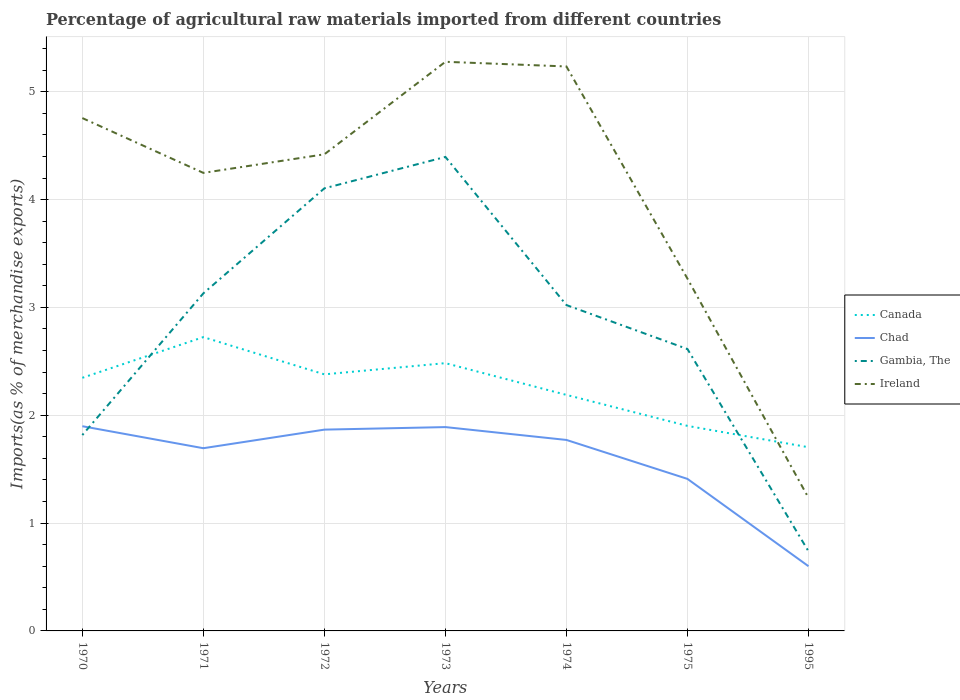How many different coloured lines are there?
Offer a very short reply. 4. Does the line corresponding to Gambia, The intersect with the line corresponding to Canada?
Your answer should be very brief. Yes. Is the number of lines equal to the number of legend labels?
Give a very brief answer. Yes. Across all years, what is the maximum percentage of imports to different countries in Gambia, The?
Your answer should be very brief. 0.74. What is the total percentage of imports to different countries in Gambia, The in the graph?
Your answer should be compact. 2.28. What is the difference between the highest and the second highest percentage of imports to different countries in Ireland?
Make the answer very short. 4.04. How many years are there in the graph?
Offer a terse response. 7. What is the difference between two consecutive major ticks on the Y-axis?
Keep it short and to the point. 1. Does the graph contain any zero values?
Provide a short and direct response. No. Does the graph contain grids?
Ensure brevity in your answer.  Yes. How many legend labels are there?
Give a very brief answer. 4. How are the legend labels stacked?
Offer a terse response. Vertical. What is the title of the graph?
Provide a short and direct response. Percentage of agricultural raw materials imported from different countries. What is the label or title of the X-axis?
Provide a short and direct response. Years. What is the label or title of the Y-axis?
Offer a very short reply. Imports(as % of merchandise exports). What is the Imports(as % of merchandise exports) of Canada in 1970?
Offer a very short reply. 2.35. What is the Imports(as % of merchandise exports) in Chad in 1970?
Your answer should be very brief. 1.9. What is the Imports(as % of merchandise exports) of Gambia, The in 1970?
Your response must be concise. 1.82. What is the Imports(as % of merchandise exports) in Ireland in 1970?
Your answer should be very brief. 4.76. What is the Imports(as % of merchandise exports) in Canada in 1971?
Keep it short and to the point. 2.72. What is the Imports(as % of merchandise exports) of Chad in 1971?
Offer a very short reply. 1.69. What is the Imports(as % of merchandise exports) in Gambia, The in 1971?
Give a very brief answer. 3.13. What is the Imports(as % of merchandise exports) of Ireland in 1971?
Your response must be concise. 4.25. What is the Imports(as % of merchandise exports) of Canada in 1972?
Your answer should be compact. 2.38. What is the Imports(as % of merchandise exports) in Chad in 1972?
Make the answer very short. 1.87. What is the Imports(as % of merchandise exports) of Gambia, The in 1972?
Keep it short and to the point. 4.1. What is the Imports(as % of merchandise exports) in Ireland in 1972?
Give a very brief answer. 4.42. What is the Imports(as % of merchandise exports) in Canada in 1973?
Your answer should be compact. 2.48. What is the Imports(as % of merchandise exports) in Chad in 1973?
Give a very brief answer. 1.89. What is the Imports(as % of merchandise exports) in Gambia, The in 1973?
Make the answer very short. 4.4. What is the Imports(as % of merchandise exports) of Ireland in 1973?
Offer a very short reply. 5.28. What is the Imports(as % of merchandise exports) of Canada in 1974?
Offer a terse response. 2.19. What is the Imports(as % of merchandise exports) in Chad in 1974?
Make the answer very short. 1.77. What is the Imports(as % of merchandise exports) of Gambia, The in 1974?
Offer a terse response. 3.02. What is the Imports(as % of merchandise exports) in Ireland in 1974?
Your response must be concise. 5.23. What is the Imports(as % of merchandise exports) in Canada in 1975?
Your response must be concise. 1.9. What is the Imports(as % of merchandise exports) in Chad in 1975?
Your response must be concise. 1.41. What is the Imports(as % of merchandise exports) of Gambia, The in 1975?
Offer a very short reply. 2.61. What is the Imports(as % of merchandise exports) of Ireland in 1975?
Provide a succinct answer. 3.27. What is the Imports(as % of merchandise exports) of Canada in 1995?
Your answer should be compact. 1.7. What is the Imports(as % of merchandise exports) of Chad in 1995?
Offer a very short reply. 0.6. What is the Imports(as % of merchandise exports) in Gambia, The in 1995?
Offer a terse response. 0.74. What is the Imports(as % of merchandise exports) in Ireland in 1995?
Make the answer very short. 1.23. Across all years, what is the maximum Imports(as % of merchandise exports) in Canada?
Offer a very short reply. 2.72. Across all years, what is the maximum Imports(as % of merchandise exports) in Chad?
Your answer should be very brief. 1.9. Across all years, what is the maximum Imports(as % of merchandise exports) of Gambia, The?
Offer a terse response. 4.4. Across all years, what is the maximum Imports(as % of merchandise exports) in Ireland?
Keep it short and to the point. 5.28. Across all years, what is the minimum Imports(as % of merchandise exports) in Canada?
Provide a short and direct response. 1.7. Across all years, what is the minimum Imports(as % of merchandise exports) of Chad?
Offer a terse response. 0.6. Across all years, what is the minimum Imports(as % of merchandise exports) of Gambia, The?
Your answer should be very brief. 0.74. Across all years, what is the minimum Imports(as % of merchandise exports) in Ireland?
Your answer should be very brief. 1.23. What is the total Imports(as % of merchandise exports) in Canada in the graph?
Ensure brevity in your answer.  15.73. What is the total Imports(as % of merchandise exports) in Chad in the graph?
Ensure brevity in your answer.  11.13. What is the total Imports(as % of merchandise exports) of Gambia, The in the graph?
Provide a short and direct response. 19.82. What is the total Imports(as % of merchandise exports) in Ireland in the graph?
Your answer should be compact. 28.44. What is the difference between the Imports(as % of merchandise exports) of Canada in 1970 and that in 1971?
Your response must be concise. -0.38. What is the difference between the Imports(as % of merchandise exports) of Chad in 1970 and that in 1971?
Offer a terse response. 0.2. What is the difference between the Imports(as % of merchandise exports) of Gambia, The in 1970 and that in 1971?
Offer a very short reply. -1.31. What is the difference between the Imports(as % of merchandise exports) in Ireland in 1970 and that in 1971?
Keep it short and to the point. 0.51. What is the difference between the Imports(as % of merchandise exports) in Canada in 1970 and that in 1972?
Give a very brief answer. -0.03. What is the difference between the Imports(as % of merchandise exports) of Chad in 1970 and that in 1972?
Provide a succinct answer. 0.03. What is the difference between the Imports(as % of merchandise exports) in Gambia, The in 1970 and that in 1972?
Your answer should be compact. -2.29. What is the difference between the Imports(as % of merchandise exports) of Ireland in 1970 and that in 1972?
Make the answer very short. 0.34. What is the difference between the Imports(as % of merchandise exports) of Canada in 1970 and that in 1973?
Make the answer very short. -0.14. What is the difference between the Imports(as % of merchandise exports) in Chad in 1970 and that in 1973?
Keep it short and to the point. 0.01. What is the difference between the Imports(as % of merchandise exports) of Gambia, The in 1970 and that in 1973?
Your answer should be compact. -2.58. What is the difference between the Imports(as % of merchandise exports) of Ireland in 1970 and that in 1973?
Your response must be concise. -0.52. What is the difference between the Imports(as % of merchandise exports) of Canada in 1970 and that in 1974?
Give a very brief answer. 0.16. What is the difference between the Imports(as % of merchandise exports) in Chad in 1970 and that in 1974?
Give a very brief answer. 0.13. What is the difference between the Imports(as % of merchandise exports) in Gambia, The in 1970 and that in 1974?
Provide a short and direct response. -1.21. What is the difference between the Imports(as % of merchandise exports) in Ireland in 1970 and that in 1974?
Make the answer very short. -0.48. What is the difference between the Imports(as % of merchandise exports) in Canada in 1970 and that in 1975?
Offer a terse response. 0.45. What is the difference between the Imports(as % of merchandise exports) in Chad in 1970 and that in 1975?
Give a very brief answer. 0.49. What is the difference between the Imports(as % of merchandise exports) in Gambia, The in 1970 and that in 1975?
Ensure brevity in your answer.  -0.8. What is the difference between the Imports(as % of merchandise exports) in Ireland in 1970 and that in 1975?
Offer a terse response. 1.49. What is the difference between the Imports(as % of merchandise exports) of Canada in 1970 and that in 1995?
Your answer should be very brief. 0.64. What is the difference between the Imports(as % of merchandise exports) of Chad in 1970 and that in 1995?
Offer a terse response. 1.3. What is the difference between the Imports(as % of merchandise exports) in Gambia, The in 1970 and that in 1995?
Offer a terse response. 1.08. What is the difference between the Imports(as % of merchandise exports) in Ireland in 1970 and that in 1995?
Offer a very short reply. 3.52. What is the difference between the Imports(as % of merchandise exports) in Canada in 1971 and that in 1972?
Offer a very short reply. 0.35. What is the difference between the Imports(as % of merchandise exports) of Chad in 1971 and that in 1972?
Your answer should be very brief. -0.17. What is the difference between the Imports(as % of merchandise exports) in Gambia, The in 1971 and that in 1972?
Your answer should be compact. -0.97. What is the difference between the Imports(as % of merchandise exports) of Ireland in 1971 and that in 1972?
Ensure brevity in your answer.  -0.17. What is the difference between the Imports(as % of merchandise exports) of Canada in 1971 and that in 1973?
Keep it short and to the point. 0.24. What is the difference between the Imports(as % of merchandise exports) of Chad in 1971 and that in 1973?
Your answer should be compact. -0.2. What is the difference between the Imports(as % of merchandise exports) in Gambia, The in 1971 and that in 1973?
Your response must be concise. -1.26. What is the difference between the Imports(as % of merchandise exports) of Ireland in 1971 and that in 1973?
Ensure brevity in your answer.  -1.03. What is the difference between the Imports(as % of merchandise exports) of Canada in 1971 and that in 1974?
Provide a succinct answer. 0.54. What is the difference between the Imports(as % of merchandise exports) in Chad in 1971 and that in 1974?
Your answer should be very brief. -0.08. What is the difference between the Imports(as % of merchandise exports) of Gambia, The in 1971 and that in 1974?
Your response must be concise. 0.11. What is the difference between the Imports(as % of merchandise exports) in Ireland in 1971 and that in 1974?
Give a very brief answer. -0.99. What is the difference between the Imports(as % of merchandise exports) in Canada in 1971 and that in 1975?
Offer a very short reply. 0.82. What is the difference between the Imports(as % of merchandise exports) of Chad in 1971 and that in 1975?
Ensure brevity in your answer.  0.28. What is the difference between the Imports(as % of merchandise exports) in Gambia, The in 1971 and that in 1975?
Give a very brief answer. 0.52. What is the difference between the Imports(as % of merchandise exports) of Ireland in 1971 and that in 1975?
Make the answer very short. 0.98. What is the difference between the Imports(as % of merchandise exports) in Canada in 1971 and that in 1995?
Make the answer very short. 1.02. What is the difference between the Imports(as % of merchandise exports) in Chad in 1971 and that in 1995?
Offer a very short reply. 1.09. What is the difference between the Imports(as % of merchandise exports) of Gambia, The in 1971 and that in 1995?
Offer a terse response. 2.39. What is the difference between the Imports(as % of merchandise exports) in Ireland in 1971 and that in 1995?
Provide a succinct answer. 3.01. What is the difference between the Imports(as % of merchandise exports) in Canada in 1972 and that in 1973?
Provide a short and direct response. -0.1. What is the difference between the Imports(as % of merchandise exports) of Chad in 1972 and that in 1973?
Offer a terse response. -0.02. What is the difference between the Imports(as % of merchandise exports) of Gambia, The in 1972 and that in 1973?
Give a very brief answer. -0.29. What is the difference between the Imports(as % of merchandise exports) in Ireland in 1972 and that in 1973?
Offer a terse response. -0.86. What is the difference between the Imports(as % of merchandise exports) in Canada in 1972 and that in 1974?
Your answer should be compact. 0.19. What is the difference between the Imports(as % of merchandise exports) of Chad in 1972 and that in 1974?
Keep it short and to the point. 0.1. What is the difference between the Imports(as % of merchandise exports) in Gambia, The in 1972 and that in 1974?
Offer a terse response. 1.08. What is the difference between the Imports(as % of merchandise exports) in Ireland in 1972 and that in 1974?
Offer a very short reply. -0.81. What is the difference between the Imports(as % of merchandise exports) in Canada in 1972 and that in 1975?
Your answer should be very brief. 0.48. What is the difference between the Imports(as % of merchandise exports) in Chad in 1972 and that in 1975?
Your response must be concise. 0.46. What is the difference between the Imports(as % of merchandise exports) of Gambia, The in 1972 and that in 1975?
Offer a very short reply. 1.49. What is the difference between the Imports(as % of merchandise exports) of Ireland in 1972 and that in 1975?
Keep it short and to the point. 1.15. What is the difference between the Imports(as % of merchandise exports) in Canada in 1972 and that in 1995?
Provide a succinct answer. 0.68. What is the difference between the Imports(as % of merchandise exports) in Chad in 1972 and that in 1995?
Make the answer very short. 1.27. What is the difference between the Imports(as % of merchandise exports) in Gambia, The in 1972 and that in 1995?
Make the answer very short. 3.37. What is the difference between the Imports(as % of merchandise exports) in Ireland in 1972 and that in 1995?
Ensure brevity in your answer.  3.19. What is the difference between the Imports(as % of merchandise exports) of Canada in 1973 and that in 1974?
Offer a terse response. 0.29. What is the difference between the Imports(as % of merchandise exports) in Chad in 1973 and that in 1974?
Your response must be concise. 0.12. What is the difference between the Imports(as % of merchandise exports) of Gambia, The in 1973 and that in 1974?
Offer a very short reply. 1.37. What is the difference between the Imports(as % of merchandise exports) of Ireland in 1973 and that in 1974?
Your answer should be very brief. 0.04. What is the difference between the Imports(as % of merchandise exports) in Canada in 1973 and that in 1975?
Ensure brevity in your answer.  0.58. What is the difference between the Imports(as % of merchandise exports) in Chad in 1973 and that in 1975?
Ensure brevity in your answer.  0.48. What is the difference between the Imports(as % of merchandise exports) in Gambia, The in 1973 and that in 1975?
Your response must be concise. 1.78. What is the difference between the Imports(as % of merchandise exports) in Ireland in 1973 and that in 1975?
Provide a short and direct response. 2.01. What is the difference between the Imports(as % of merchandise exports) in Canada in 1973 and that in 1995?
Make the answer very short. 0.78. What is the difference between the Imports(as % of merchandise exports) of Chad in 1973 and that in 1995?
Provide a succinct answer. 1.29. What is the difference between the Imports(as % of merchandise exports) of Gambia, The in 1973 and that in 1995?
Make the answer very short. 3.66. What is the difference between the Imports(as % of merchandise exports) of Ireland in 1973 and that in 1995?
Keep it short and to the point. 4.04. What is the difference between the Imports(as % of merchandise exports) of Canada in 1974 and that in 1975?
Your answer should be very brief. 0.29. What is the difference between the Imports(as % of merchandise exports) of Chad in 1974 and that in 1975?
Provide a short and direct response. 0.36. What is the difference between the Imports(as % of merchandise exports) of Gambia, The in 1974 and that in 1975?
Ensure brevity in your answer.  0.41. What is the difference between the Imports(as % of merchandise exports) of Ireland in 1974 and that in 1975?
Your response must be concise. 1.97. What is the difference between the Imports(as % of merchandise exports) in Canada in 1974 and that in 1995?
Offer a terse response. 0.49. What is the difference between the Imports(as % of merchandise exports) of Chad in 1974 and that in 1995?
Give a very brief answer. 1.17. What is the difference between the Imports(as % of merchandise exports) in Gambia, The in 1974 and that in 1995?
Provide a succinct answer. 2.28. What is the difference between the Imports(as % of merchandise exports) of Canada in 1975 and that in 1995?
Provide a succinct answer. 0.2. What is the difference between the Imports(as % of merchandise exports) in Chad in 1975 and that in 1995?
Your answer should be compact. 0.81. What is the difference between the Imports(as % of merchandise exports) of Gambia, The in 1975 and that in 1995?
Ensure brevity in your answer.  1.88. What is the difference between the Imports(as % of merchandise exports) of Ireland in 1975 and that in 1995?
Provide a succinct answer. 2.03. What is the difference between the Imports(as % of merchandise exports) in Canada in 1970 and the Imports(as % of merchandise exports) in Chad in 1971?
Your answer should be very brief. 0.65. What is the difference between the Imports(as % of merchandise exports) of Canada in 1970 and the Imports(as % of merchandise exports) of Gambia, The in 1971?
Offer a terse response. -0.78. What is the difference between the Imports(as % of merchandise exports) in Canada in 1970 and the Imports(as % of merchandise exports) in Ireland in 1971?
Ensure brevity in your answer.  -1.9. What is the difference between the Imports(as % of merchandise exports) of Chad in 1970 and the Imports(as % of merchandise exports) of Gambia, The in 1971?
Provide a short and direct response. -1.23. What is the difference between the Imports(as % of merchandise exports) in Chad in 1970 and the Imports(as % of merchandise exports) in Ireland in 1971?
Keep it short and to the point. -2.35. What is the difference between the Imports(as % of merchandise exports) in Gambia, The in 1970 and the Imports(as % of merchandise exports) in Ireland in 1971?
Provide a succinct answer. -2.43. What is the difference between the Imports(as % of merchandise exports) in Canada in 1970 and the Imports(as % of merchandise exports) in Chad in 1972?
Your answer should be compact. 0.48. What is the difference between the Imports(as % of merchandise exports) of Canada in 1970 and the Imports(as % of merchandise exports) of Gambia, The in 1972?
Offer a very short reply. -1.76. What is the difference between the Imports(as % of merchandise exports) of Canada in 1970 and the Imports(as % of merchandise exports) of Ireland in 1972?
Make the answer very short. -2.07. What is the difference between the Imports(as % of merchandise exports) in Chad in 1970 and the Imports(as % of merchandise exports) in Gambia, The in 1972?
Ensure brevity in your answer.  -2.21. What is the difference between the Imports(as % of merchandise exports) of Chad in 1970 and the Imports(as % of merchandise exports) of Ireland in 1972?
Offer a terse response. -2.52. What is the difference between the Imports(as % of merchandise exports) of Gambia, The in 1970 and the Imports(as % of merchandise exports) of Ireland in 1972?
Your answer should be very brief. -2.6. What is the difference between the Imports(as % of merchandise exports) of Canada in 1970 and the Imports(as % of merchandise exports) of Chad in 1973?
Ensure brevity in your answer.  0.46. What is the difference between the Imports(as % of merchandise exports) of Canada in 1970 and the Imports(as % of merchandise exports) of Gambia, The in 1973?
Give a very brief answer. -2.05. What is the difference between the Imports(as % of merchandise exports) of Canada in 1970 and the Imports(as % of merchandise exports) of Ireland in 1973?
Keep it short and to the point. -2.93. What is the difference between the Imports(as % of merchandise exports) of Chad in 1970 and the Imports(as % of merchandise exports) of Gambia, The in 1973?
Provide a short and direct response. -2.5. What is the difference between the Imports(as % of merchandise exports) in Chad in 1970 and the Imports(as % of merchandise exports) in Ireland in 1973?
Make the answer very short. -3.38. What is the difference between the Imports(as % of merchandise exports) in Gambia, The in 1970 and the Imports(as % of merchandise exports) in Ireland in 1973?
Your answer should be compact. -3.46. What is the difference between the Imports(as % of merchandise exports) in Canada in 1970 and the Imports(as % of merchandise exports) in Chad in 1974?
Offer a terse response. 0.58. What is the difference between the Imports(as % of merchandise exports) of Canada in 1970 and the Imports(as % of merchandise exports) of Gambia, The in 1974?
Ensure brevity in your answer.  -0.67. What is the difference between the Imports(as % of merchandise exports) in Canada in 1970 and the Imports(as % of merchandise exports) in Ireland in 1974?
Offer a very short reply. -2.89. What is the difference between the Imports(as % of merchandise exports) of Chad in 1970 and the Imports(as % of merchandise exports) of Gambia, The in 1974?
Offer a very short reply. -1.12. What is the difference between the Imports(as % of merchandise exports) in Chad in 1970 and the Imports(as % of merchandise exports) in Ireland in 1974?
Ensure brevity in your answer.  -3.34. What is the difference between the Imports(as % of merchandise exports) of Gambia, The in 1970 and the Imports(as % of merchandise exports) of Ireland in 1974?
Your response must be concise. -3.42. What is the difference between the Imports(as % of merchandise exports) of Canada in 1970 and the Imports(as % of merchandise exports) of Gambia, The in 1975?
Give a very brief answer. -0.27. What is the difference between the Imports(as % of merchandise exports) of Canada in 1970 and the Imports(as % of merchandise exports) of Ireland in 1975?
Offer a very short reply. -0.92. What is the difference between the Imports(as % of merchandise exports) of Chad in 1970 and the Imports(as % of merchandise exports) of Gambia, The in 1975?
Your answer should be compact. -0.72. What is the difference between the Imports(as % of merchandise exports) of Chad in 1970 and the Imports(as % of merchandise exports) of Ireland in 1975?
Provide a succinct answer. -1.37. What is the difference between the Imports(as % of merchandise exports) in Gambia, The in 1970 and the Imports(as % of merchandise exports) in Ireland in 1975?
Offer a terse response. -1.45. What is the difference between the Imports(as % of merchandise exports) in Canada in 1970 and the Imports(as % of merchandise exports) in Chad in 1995?
Provide a succinct answer. 1.75. What is the difference between the Imports(as % of merchandise exports) in Canada in 1970 and the Imports(as % of merchandise exports) in Gambia, The in 1995?
Ensure brevity in your answer.  1.61. What is the difference between the Imports(as % of merchandise exports) in Canada in 1970 and the Imports(as % of merchandise exports) in Ireland in 1995?
Your response must be concise. 1.11. What is the difference between the Imports(as % of merchandise exports) in Chad in 1970 and the Imports(as % of merchandise exports) in Gambia, The in 1995?
Ensure brevity in your answer.  1.16. What is the difference between the Imports(as % of merchandise exports) of Chad in 1970 and the Imports(as % of merchandise exports) of Ireland in 1995?
Your response must be concise. 0.66. What is the difference between the Imports(as % of merchandise exports) in Gambia, The in 1970 and the Imports(as % of merchandise exports) in Ireland in 1995?
Offer a terse response. 0.58. What is the difference between the Imports(as % of merchandise exports) in Canada in 1971 and the Imports(as % of merchandise exports) in Chad in 1972?
Your answer should be very brief. 0.86. What is the difference between the Imports(as % of merchandise exports) of Canada in 1971 and the Imports(as % of merchandise exports) of Gambia, The in 1972?
Your answer should be compact. -1.38. What is the difference between the Imports(as % of merchandise exports) in Canada in 1971 and the Imports(as % of merchandise exports) in Ireland in 1972?
Give a very brief answer. -1.7. What is the difference between the Imports(as % of merchandise exports) in Chad in 1971 and the Imports(as % of merchandise exports) in Gambia, The in 1972?
Your response must be concise. -2.41. What is the difference between the Imports(as % of merchandise exports) of Chad in 1971 and the Imports(as % of merchandise exports) of Ireland in 1972?
Offer a very short reply. -2.73. What is the difference between the Imports(as % of merchandise exports) of Gambia, The in 1971 and the Imports(as % of merchandise exports) of Ireland in 1972?
Provide a succinct answer. -1.29. What is the difference between the Imports(as % of merchandise exports) in Canada in 1971 and the Imports(as % of merchandise exports) in Chad in 1973?
Your answer should be compact. 0.83. What is the difference between the Imports(as % of merchandise exports) in Canada in 1971 and the Imports(as % of merchandise exports) in Gambia, The in 1973?
Give a very brief answer. -1.67. What is the difference between the Imports(as % of merchandise exports) of Canada in 1971 and the Imports(as % of merchandise exports) of Ireland in 1973?
Offer a terse response. -2.55. What is the difference between the Imports(as % of merchandise exports) of Chad in 1971 and the Imports(as % of merchandise exports) of Gambia, The in 1973?
Make the answer very short. -2.7. What is the difference between the Imports(as % of merchandise exports) of Chad in 1971 and the Imports(as % of merchandise exports) of Ireland in 1973?
Make the answer very short. -3.58. What is the difference between the Imports(as % of merchandise exports) of Gambia, The in 1971 and the Imports(as % of merchandise exports) of Ireland in 1973?
Offer a very short reply. -2.15. What is the difference between the Imports(as % of merchandise exports) in Canada in 1971 and the Imports(as % of merchandise exports) in Chad in 1974?
Give a very brief answer. 0.95. What is the difference between the Imports(as % of merchandise exports) of Canada in 1971 and the Imports(as % of merchandise exports) of Gambia, The in 1974?
Offer a very short reply. -0.3. What is the difference between the Imports(as % of merchandise exports) of Canada in 1971 and the Imports(as % of merchandise exports) of Ireland in 1974?
Your answer should be compact. -2.51. What is the difference between the Imports(as % of merchandise exports) of Chad in 1971 and the Imports(as % of merchandise exports) of Gambia, The in 1974?
Your answer should be very brief. -1.33. What is the difference between the Imports(as % of merchandise exports) in Chad in 1971 and the Imports(as % of merchandise exports) in Ireland in 1974?
Offer a terse response. -3.54. What is the difference between the Imports(as % of merchandise exports) of Gambia, The in 1971 and the Imports(as % of merchandise exports) of Ireland in 1974?
Keep it short and to the point. -2.1. What is the difference between the Imports(as % of merchandise exports) of Canada in 1971 and the Imports(as % of merchandise exports) of Chad in 1975?
Provide a succinct answer. 1.31. What is the difference between the Imports(as % of merchandise exports) of Canada in 1971 and the Imports(as % of merchandise exports) of Gambia, The in 1975?
Your answer should be very brief. 0.11. What is the difference between the Imports(as % of merchandise exports) of Canada in 1971 and the Imports(as % of merchandise exports) of Ireland in 1975?
Keep it short and to the point. -0.54. What is the difference between the Imports(as % of merchandise exports) of Chad in 1971 and the Imports(as % of merchandise exports) of Gambia, The in 1975?
Provide a short and direct response. -0.92. What is the difference between the Imports(as % of merchandise exports) in Chad in 1971 and the Imports(as % of merchandise exports) in Ireland in 1975?
Provide a succinct answer. -1.57. What is the difference between the Imports(as % of merchandise exports) in Gambia, The in 1971 and the Imports(as % of merchandise exports) in Ireland in 1975?
Keep it short and to the point. -0.14. What is the difference between the Imports(as % of merchandise exports) in Canada in 1971 and the Imports(as % of merchandise exports) in Chad in 1995?
Offer a terse response. 2.12. What is the difference between the Imports(as % of merchandise exports) in Canada in 1971 and the Imports(as % of merchandise exports) in Gambia, The in 1995?
Offer a very short reply. 1.99. What is the difference between the Imports(as % of merchandise exports) of Canada in 1971 and the Imports(as % of merchandise exports) of Ireland in 1995?
Ensure brevity in your answer.  1.49. What is the difference between the Imports(as % of merchandise exports) in Chad in 1971 and the Imports(as % of merchandise exports) in Gambia, The in 1995?
Offer a terse response. 0.96. What is the difference between the Imports(as % of merchandise exports) in Chad in 1971 and the Imports(as % of merchandise exports) in Ireland in 1995?
Your answer should be compact. 0.46. What is the difference between the Imports(as % of merchandise exports) of Gambia, The in 1971 and the Imports(as % of merchandise exports) of Ireland in 1995?
Your answer should be very brief. 1.9. What is the difference between the Imports(as % of merchandise exports) of Canada in 1972 and the Imports(as % of merchandise exports) of Chad in 1973?
Your answer should be very brief. 0.49. What is the difference between the Imports(as % of merchandise exports) of Canada in 1972 and the Imports(as % of merchandise exports) of Gambia, The in 1973?
Provide a short and direct response. -2.02. What is the difference between the Imports(as % of merchandise exports) in Canada in 1972 and the Imports(as % of merchandise exports) in Ireland in 1973?
Your response must be concise. -2.9. What is the difference between the Imports(as % of merchandise exports) of Chad in 1972 and the Imports(as % of merchandise exports) of Gambia, The in 1973?
Provide a succinct answer. -2.53. What is the difference between the Imports(as % of merchandise exports) in Chad in 1972 and the Imports(as % of merchandise exports) in Ireland in 1973?
Give a very brief answer. -3.41. What is the difference between the Imports(as % of merchandise exports) of Gambia, The in 1972 and the Imports(as % of merchandise exports) of Ireland in 1973?
Give a very brief answer. -1.17. What is the difference between the Imports(as % of merchandise exports) in Canada in 1972 and the Imports(as % of merchandise exports) in Chad in 1974?
Your answer should be very brief. 0.61. What is the difference between the Imports(as % of merchandise exports) of Canada in 1972 and the Imports(as % of merchandise exports) of Gambia, The in 1974?
Provide a short and direct response. -0.64. What is the difference between the Imports(as % of merchandise exports) of Canada in 1972 and the Imports(as % of merchandise exports) of Ireland in 1974?
Your answer should be very brief. -2.86. What is the difference between the Imports(as % of merchandise exports) of Chad in 1972 and the Imports(as % of merchandise exports) of Gambia, The in 1974?
Your response must be concise. -1.16. What is the difference between the Imports(as % of merchandise exports) in Chad in 1972 and the Imports(as % of merchandise exports) in Ireland in 1974?
Your answer should be compact. -3.37. What is the difference between the Imports(as % of merchandise exports) in Gambia, The in 1972 and the Imports(as % of merchandise exports) in Ireland in 1974?
Your answer should be very brief. -1.13. What is the difference between the Imports(as % of merchandise exports) of Canada in 1972 and the Imports(as % of merchandise exports) of Chad in 1975?
Your answer should be compact. 0.97. What is the difference between the Imports(as % of merchandise exports) of Canada in 1972 and the Imports(as % of merchandise exports) of Gambia, The in 1975?
Provide a short and direct response. -0.23. What is the difference between the Imports(as % of merchandise exports) of Canada in 1972 and the Imports(as % of merchandise exports) of Ireland in 1975?
Keep it short and to the point. -0.89. What is the difference between the Imports(as % of merchandise exports) in Chad in 1972 and the Imports(as % of merchandise exports) in Gambia, The in 1975?
Your answer should be very brief. -0.75. What is the difference between the Imports(as % of merchandise exports) in Chad in 1972 and the Imports(as % of merchandise exports) in Ireland in 1975?
Provide a succinct answer. -1.4. What is the difference between the Imports(as % of merchandise exports) in Gambia, The in 1972 and the Imports(as % of merchandise exports) in Ireland in 1975?
Your answer should be compact. 0.84. What is the difference between the Imports(as % of merchandise exports) of Canada in 1972 and the Imports(as % of merchandise exports) of Chad in 1995?
Make the answer very short. 1.78. What is the difference between the Imports(as % of merchandise exports) in Canada in 1972 and the Imports(as % of merchandise exports) in Gambia, The in 1995?
Your answer should be very brief. 1.64. What is the difference between the Imports(as % of merchandise exports) in Canada in 1972 and the Imports(as % of merchandise exports) in Ireland in 1995?
Provide a succinct answer. 1.14. What is the difference between the Imports(as % of merchandise exports) in Chad in 1972 and the Imports(as % of merchandise exports) in Gambia, The in 1995?
Your response must be concise. 1.13. What is the difference between the Imports(as % of merchandise exports) in Chad in 1972 and the Imports(as % of merchandise exports) in Ireland in 1995?
Provide a short and direct response. 0.63. What is the difference between the Imports(as % of merchandise exports) in Gambia, The in 1972 and the Imports(as % of merchandise exports) in Ireland in 1995?
Keep it short and to the point. 2.87. What is the difference between the Imports(as % of merchandise exports) in Canada in 1973 and the Imports(as % of merchandise exports) in Chad in 1974?
Give a very brief answer. 0.71. What is the difference between the Imports(as % of merchandise exports) in Canada in 1973 and the Imports(as % of merchandise exports) in Gambia, The in 1974?
Offer a terse response. -0.54. What is the difference between the Imports(as % of merchandise exports) of Canada in 1973 and the Imports(as % of merchandise exports) of Ireland in 1974?
Offer a very short reply. -2.75. What is the difference between the Imports(as % of merchandise exports) in Chad in 1973 and the Imports(as % of merchandise exports) in Gambia, The in 1974?
Keep it short and to the point. -1.13. What is the difference between the Imports(as % of merchandise exports) of Chad in 1973 and the Imports(as % of merchandise exports) of Ireland in 1974?
Provide a succinct answer. -3.34. What is the difference between the Imports(as % of merchandise exports) of Gambia, The in 1973 and the Imports(as % of merchandise exports) of Ireland in 1974?
Provide a succinct answer. -0.84. What is the difference between the Imports(as % of merchandise exports) in Canada in 1973 and the Imports(as % of merchandise exports) in Chad in 1975?
Make the answer very short. 1.07. What is the difference between the Imports(as % of merchandise exports) of Canada in 1973 and the Imports(as % of merchandise exports) of Gambia, The in 1975?
Make the answer very short. -0.13. What is the difference between the Imports(as % of merchandise exports) of Canada in 1973 and the Imports(as % of merchandise exports) of Ireland in 1975?
Offer a very short reply. -0.78. What is the difference between the Imports(as % of merchandise exports) of Chad in 1973 and the Imports(as % of merchandise exports) of Gambia, The in 1975?
Provide a succinct answer. -0.72. What is the difference between the Imports(as % of merchandise exports) in Chad in 1973 and the Imports(as % of merchandise exports) in Ireland in 1975?
Your response must be concise. -1.38. What is the difference between the Imports(as % of merchandise exports) of Gambia, The in 1973 and the Imports(as % of merchandise exports) of Ireland in 1975?
Provide a succinct answer. 1.13. What is the difference between the Imports(as % of merchandise exports) in Canada in 1973 and the Imports(as % of merchandise exports) in Chad in 1995?
Offer a very short reply. 1.88. What is the difference between the Imports(as % of merchandise exports) of Canada in 1973 and the Imports(as % of merchandise exports) of Gambia, The in 1995?
Offer a terse response. 1.74. What is the difference between the Imports(as % of merchandise exports) of Canada in 1973 and the Imports(as % of merchandise exports) of Ireland in 1995?
Offer a terse response. 1.25. What is the difference between the Imports(as % of merchandise exports) of Chad in 1973 and the Imports(as % of merchandise exports) of Gambia, The in 1995?
Your response must be concise. 1.15. What is the difference between the Imports(as % of merchandise exports) of Chad in 1973 and the Imports(as % of merchandise exports) of Ireland in 1995?
Provide a short and direct response. 0.66. What is the difference between the Imports(as % of merchandise exports) in Gambia, The in 1973 and the Imports(as % of merchandise exports) in Ireland in 1995?
Offer a very short reply. 3.16. What is the difference between the Imports(as % of merchandise exports) of Canada in 1974 and the Imports(as % of merchandise exports) of Chad in 1975?
Provide a short and direct response. 0.78. What is the difference between the Imports(as % of merchandise exports) of Canada in 1974 and the Imports(as % of merchandise exports) of Gambia, The in 1975?
Give a very brief answer. -0.43. What is the difference between the Imports(as % of merchandise exports) of Canada in 1974 and the Imports(as % of merchandise exports) of Ireland in 1975?
Your answer should be very brief. -1.08. What is the difference between the Imports(as % of merchandise exports) of Chad in 1974 and the Imports(as % of merchandise exports) of Gambia, The in 1975?
Keep it short and to the point. -0.84. What is the difference between the Imports(as % of merchandise exports) of Chad in 1974 and the Imports(as % of merchandise exports) of Ireland in 1975?
Give a very brief answer. -1.5. What is the difference between the Imports(as % of merchandise exports) in Gambia, The in 1974 and the Imports(as % of merchandise exports) in Ireland in 1975?
Provide a short and direct response. -0.25. What is the difference between the Imports(as % of merchandise exports) in Canada in 1974 and the Imports(as % of merchandise exports) in Chad in 1995?
Offer a terse response. 1.59. What is the difference between the Imports(as % of merchandise exports) in Canada in 1974 and the Imports(as % of merchandise exports) in Gambia, The in 1995?
Your response must be concise. 1.45. What is the difference between the Imports(as % of merchandise exports) of Canada in 1974 and the Imports(as % of merchandise exports) of Ireland in 1995?
Make the answer very short. 0.95. What is the difference between the Imports(as % of merchandise exports) of Chad in 1974 and the Imports(as % of merchandise exports) of Gambia, The in 1995?
Keep it short and to the point. 1.03. What is the difference between the Imports(as % of merchandise exports) in Chad in 1974 and the Imports(as % of merchandise exports) in Ireland in 1995?
Your answer should be compact. 0.54. What is the difference between the Imports(as % of merchandise exports) in Gambia, The in 1974 and the Imports(as % of merchandise exports) in Ireland in 1995?
Keep it short and to the point. 1.79. What is the difference between the Imports(as % of merchandise exports) in Canada in 1975 and the Imports(as % of merchandise exports) in Chad in 1995?
Your response must be concise. 1.3. What is the difference between the Imports(as % of merchandise exports) in Canada in 1975 and the Imports(as % of merchandise exports) in Gambia, The in 1995?
Make the answer very short. 1.16. What is the difference between the Imports(as % of merchandise exports) in Canada in 1975 and the Imports(as % of merchandise exports) in Ireland in 1995?
Provide a short and direct response. 0.67. What is the difference between the Imports(as % of merchandise exports) of Chad in 1975 and the Imports(as % of merchandise exports) of Gambia, The in 1995?
Ensure brevity in your answer.  0.67. What is the difference between the Imports(as % of merchandise exports) of Chad in 1975 and the Imports(as % of merchandise exports) of Ireland in 1995?
Offer a terse response. 0.18. What is the difference between the Imports(as % of merchandise exports) of Gambia, The in 1975 and the Imports(as % of merchandise exports) of Ireland in 1995?
Make the answer very short. 1.38. What is the average Imports(as % of merchandise exports) of Canada per year?
Your response must be concise. 2.25. What is the average Imports(as % of merchandise exports) of Chad per year?
Your response must be concise. 1.59. What is the average Imports(as % of merchandise exports) of Gambia, The per year?
Offer a very short reply. 2.83. What is the average Imports(as % of merchandise exports) of Ireland per year?
Offer a terse response. 4.06. In the year 1970, what is the difference between the Imports(as % of merchandise exports) of Canada and Imports(as % of merchandise exports) of Chad?
Keep it short and to the point. 0.45. In the year 1970, what is the difference between the Imports(as % of merchandise exports) of Canada and Imports(as % of merchandise exports) of Gambia, The?
Offer a terse response. 0.53. In the year 1970, what is the difference between the Imports(as % of merchandise exports) in Canada and Imports(as % of merchandise exports) in Ireland?
Provide a succinct answer. -2.41. In the year 1970, what is the difference between the Imports(as % of merchandise exports) in Chad and Imports(as % of merchandise exports) in Gambia, The?
Your response must be concise. 0.08. In the year 1970, what is the difference between the Imports(as % of merchandise exports) in Chad and Imports(as % of merchandise exports) in Ireland?
Offer a very short reply. -2.86. In the year 1970, what is the difference between the Imports(as % of merchandise exports) in Gambia, The and Imports(as % of merchandise exports) in Ireland?
Your response must be concise. -2.94. In the year 1971, what is the difference between the Imports(as % of merchandise exports) of Canada and Imports(as % of merchandise exports) of Chad?
Give a very brief answer. 1.03. In the year 1971, what is the difference between the Imports(as % of merchandise exports) of Canada and Imports(as % of merchandise exports) of Gambia, The?
Keep it short and to the point. -0.41. In the year 1971, what is the difference between the Imports(as % of merchandise exports) of Canada and Imports(as % of merchandise exports) of Ireland?
Your answer should be very brief. -1.52. In the year 1971, what is the difference between the Imports(as % of merchandise exports) in Chad and Imports(as % of merchandise exports) in Gambia, The?
Your answer should be compact. -1.44. In the year 1971, what is the difference between the Imports(as % of merchandise exports) of Chad and Imports(as % of merchandise exports) of Ireland?
Your answer should be very brief. -2.55. In the year 1971, what is the difference between the Imports(as % of merchandise exports) of Gambia, The and Imports(as % of merchandise exports) of Ireland?
Offer a terse response. -1.12. In the year 1972, what is the difference between the Imports(as % of merchandise exports) of Canada and Imports(as % of merchandise exports) of Chad?
Give a very brief answer. 0.51. In the year 1972, what is the difference between the Imports(as % of merchandise exports) in Canada and Imports(as % of merchandise exports) in Gambia, The?
Give a very brief answer. -1.73. In the year 1972, what is the difference between the Imports(as % of merchandise exports) of Canada and Imports(as % of merchandise exports) of Ireland?
Your answer should be compact. -2.04. In the year 1972, what is the difference between the Imports(as % of merchandise exports) in Chad and Imports(as % of merchandise exports) in Gambia, The?
Your answer should be compact. -2.24. In the year 1972, what is the difference between the Imports(as % of merchandise exports) in Chad and Imports(as % of merchandise exports) in Ireland?
Provide a short and direct response. -2.55. In the year 1972, what is the difference between the Imports(as % of merchandise exports) in Gambia, The and Imports(as % of merchandise exports) in Ireland?
Ensure brevity in your answer.  -0.32. In the year 1973, what is the difference between the Imports(as % of merchandise exports) in Canada and Imports(as % of merchandise exports) in Chad?
Ensure brevity in your answer.  0.59. In the year 1973, what is the difference between the Imports(as % of merchandise exports) of Canada and Imports(as % of merchandise exports) of Gambia, The?
Offer a terse response. -1.91. In the year 1973, what is the difference between the Imports(as % of merchandise exports) in Canada and Imports(as % of merchandise exports) in Ireland?
Your answer should be very brief. -2.79. In the year 1973, what is the difference between the Imports(as % of merchandise exports) of Chad and Imports(as % of merchandise exports) of Gambia, The?
Make the answer very short. -2.51. In the year 1973, what is the difference between the Imports(as % of merchandise exports) in Chad and Imports(as % of merchandise exports) in Ireland?
Keep it short and to the point. -3.39. In the year 1973, what is the difference between the Imports(as % of merchandise exports) in Gambia, The and Imports(as % of merchandise exports) in Ireland?
Offer a terse response. -0.88. In the year 1974, what is the difference between the Imports(as % of merchandise exports) in Canada and Imports(as % of merchandise exports) in Chad?
Your response must be concise. 0.42. In the year 1974, what is the difference between the Imports(as % of merchandise exports) of Canada and Imports(as % of merchandise exports) of Gambia, The?
Offer a very short reply. -0.83. In the year 1974, what is the difference between the Imports(as % of merchandise exports) of Canada and Imports(as % of merchandise exports) of Ireland?
Make the answer very short. -3.05. In the year 1974, what is the difference between the Imports(as % of merchandise exports) of Chad and Imports(as % of merchandise exports) of Gambia, The?
Ensure brevity in your answer.  -1.25. In the year 1974, what is the difference between the Imports(as % of merchandise exports) of Chad and Imports(as % of merchandise exports) of Ireland?
Offer a very short reply. -3.46. In the year 1974, what is the difference between the Imports(as % of merchandise exports) in Gambia, The and Imports(as % of merchandise exports) in Ireland?
Your answer should be very brief. -2.21. In the year 1975, what is the difference between the Imports(as % of merchandise exports) of Canada and Imports(as % of merchandise exports) of Chad?
Your answer should be very brief. 0.49. In the year 1975, what is the difference between the Imports(as % of merchandise exports) in Canada and Imports(as % of merchandise exports) in Gambia, The?
Your answer should be compact. -0.71. In the year 1975, what is the difference between the Imports(as % of merchandise exports) in Canada and Imports(as % of merchandise exports) in Ireland?
Your response must be concise. -1.37. In the year 1975, what is the difference between the Imports(as % of merchandise exports) of Chad and Imports(as % of merchandise exports) of Gambia, The?
Ensure brevity in your answer.  -1.2. In the year 1975, what is the difference between the Imports(as % of merchandise exports) of Chad and Imports(as % of merchandise exports) of Ireland?
Keep it short and to the point. -1.86. In the year 1975, what is the difference between the Imports(as % of merchandise exports) of Gambia, The and Imports(as % of merchandise exports) of Ireland?
Offer a terse response. -0.65. In the year 1995, what is the difference between the Imports(as % of merchandise exports) in Canada and Imports(as % of merchandise exports) in Chad?
Provide a short and direct response. 1.1. In the year 1995, what is the difference between the Imports(as % of merchandise exports) of Canada and Imports(as % of merchandise exports) of Gambia, The?
Offer a terse response. 0.96. In the year 1995, what is the difference between the Imports(as % of merchandise exports) in Canada and Imports(as % of merchandise exports) in Ireland?
Offer a terse response. 0.47. In the year 1995, what is the difference between the Imports(as % of merchandise exports) of Chad and Imports(as % of merchandise exports) of Gambia, The?
Your answer should be compact. -0.14. In the year 1995, what is the difference between the Imports(as % of merchandise exports) of Chad and Imports(as % of merchandise exports) of Ireland?
Make the answer very short. -0.63. In the year 1995, what is the difference between the Imports(as % of merchandise exports) of Gambia, The and Imports(as % of merchandise exports) of Ireland?
Ensure brevity in your answer.  -0.5. What is the ratio of the Imports(as % of merchandise exports) of Canada in 1970 to that in 1971?
Ensure brevity in your answer.  0.86. What is the ratio of the Imports(as % of merchandise exports) in Chad in 1970 to that in 1971?
Ensure brevity in your answer.  1.12. What is the ratio of the Imports(as % of merchandise exports) in Gambia, The in 1970 to that in 1971?
Ensure brevity in your answer.  0.58. What is the ratio of the Imports(as % of merchandise exports) of Ireland in 1970 to that in 1971?
Keep it short and to the point. 1.12. What is the ratio of the Imports(as % of merchandise exports) of Canada in 1970 to that in 1972?
Your answer should be very brief. 0.99. What is the ratio of the Imports(as % of merchandise exports) of Chad in 1970 to that in 1972?
Provide a succinct answer. 1.02. What is the ratio of the Imports(as % of merchandise exports) of Gambia, The in 1970 to that in 1972?
Your answer should be compact. 0.44. What is the ratio of the Imports(as % of merchandise exports) of Ireland in 1970 to that in 1972?
Offer a terse response. 1.08. What is the ratio of the Imports(as % of merchandise exports) in Canada in 1970 to that in 1973?
Keep it short and to the point. 0.95. What is the ratio of the Imports(as % of merchandise exports) in Gambia, The in 1970 to that in 1973?
Provide a short and direct response. 0.41. What is the ratio of the Imports(as % of merchandise exports) in Ireland in 1970 to that in 1973?
Your response must be concise. 0.9. What is the ratio of the Imports(as % of merchandise exports) in Canada in 1970 to that in 1974?
Provide a short and direct response. 1.07. What is the ratio of the Imports(as % of merchandise exports) in Chad in 1970 to that in 1974?
Ensure brevity in your answer.  1.07. What is the ratio of the Imports(as % of merchandise exports) of Gambia, The in 1970 to that in 1974?
Make the answer very short. 0.6. What is the ratio of the Imports(as % of merchandise exports) in Ireland in 1970 to that in 1974?
Offer a very short reply. 0.91. What is the ratio of the Imports(as % of merchandise exports) of Canada in 1970 to that in 1975?
Provide a succinct answer. 1.23. What is the ratio of the Imports(as % of merchandise exports) of Chad in 1970 to that in 1975?
Keep it short and to the point. 1.35. What is the ratio of the Imports(as % of merchandise exports) of Gambia, The in 1970 to that in 1975?
Give a very brief answer. 0.69. What is the ratio of the Imports(as % of merchandise exports) of Ireland in 1970 to that in 1975?
Offer a very short reply. 1.46. What is the ratio of the Imports(as % of merchandise exports) of Canada in 1970 to that in 1995?
Give a very brief answer. 1.38. What is the ratio of the Imports(as % of merchandise exports) of Chad in 1970 to that in 1995?
Your answer should be compact. 3.16. What is the ratio of the Imports(as % of merchandise exports) of Gambia, The in 1970 to that in 1995?
Offer a terse response. 2.46. What is the ratio of the Imports(as % of merchandise exports) of Ireland in 1970 to that in 1995?
Your answer should be very brief. 3.85. What is the ratio of the Imports(as % of merchandise exports) in Canada in 1971 to that in 1972?
Your answer should be very brief. 1.15. What is the ratio of the Imports(as % of merchandise exports) of Chad in 1971 to that in 1972?
Give a very brief answer. 0.91. What is the ratio of the Imports(as % of merchandise exports) in Gambia, The in 1971 to that in 1972?
Make the answer very short. 0.76. What is the ratio of the Imports(as % of merchandise exports) in Ireland in 1971 to that in 1972?
Provide a short and direct response. 0.96. What is the ratio of the Imports(as % of merchandise exports) of Canada in 1971 to that in 1973?
Provide a short and direct response. 1.1. What is the ratio of the Imports(as % of merchandise exports) of Chad in 1971 to that in 1973?
Offer a very short reply. 0.9. What is the ratio of the Imports(as % of merchandise exports) in Gambia, The in 1971 to that in 1973?
Make the answer very short. 0.71. What is the ratio of the Imports(as % of merchandise exports) of Ireland in 1971 to that in 1973?
Ensure brevity in your answer.  0.8. What is the ratio of the Imports(as % of merchandise exports) of Canada in 1971 to that in 1974?
Ensure brevity in your answer.  1.24. What is the ratio of the Imports(as % of merchandise exports) of Chad in 1971 to that in 1974?
Provide a succinct answer. 0.96. What is the ratio of the Imports(as % of merchandise exports) in Gambia, The in 1971 to that in 1974?
Provide a succinct answer. 1.04. What is the ratio of the Imports(as % of merchandise exports) in Ireland in 1971 to that in 1974?
Provide a succinct answer. 0.81. What is the ratio of the Imports(as % of merchandise exports) of Canada in 1971 to that in 1975?
Your answer should be very brief. 1.43. What is the ratio of the Imports(as % of merchandise exports) of Chad in 1971 to that in 1975?
Give a very brief answer. 1.2. What is the ratio of the Imports(as % of merchandise exports) in Gambia, The in 1971 to that in 1975?
Ensure brevity in your answer.  1.2. What is the ratio of the Imports(as % of merchandise exports) of Ireland in 1971 to that in 1975?
Make the answer very short. 1.3. What is the ratio of the Imports(as % of merchandise exports) of Canada in 1971 to that in 1995?
Provide a short and direct response. 1.6. What is the ratio of the Imports(as % of merchandise exports) of Chad in 1971 to that in 1995?
Keep it short and to the point. 2.82. What is the ratio of the Imports(as % of merchandise exports) in Gambia, The in 1971 to that in 1995?
Provide a short and direct response. 4.24. What is the ratio of the Imports(as % of merchandise exports) of Ireland in 1971 to that in 1995?
Offer a very short reply. 3.44. What is the ratio of the Imports(as % of merchandise exports) in Canada in 1972 to that in 1973?
Your answer should be very brief. 0.96. What is the ratio of the Imports(as % of merchandise exports) of Chad in 1972 to that in 1973?
Your answer should be very brief. 0.99. What is the ratio of the Imports(as % of merchandise exports) in Gambia, The in 1972 to that in 1973?
Offer a very short reply. 0.93. What is the ratio of the Imports(as % of merchandise exports) of Ireland in 1972 to that in 1973?
Ensure brevity in your answer.  0.84. What is the ratio of the Imports(as % of merchandise exports) of Canada in 1972 to that in 1974?
Offer a terse response. 1.09. What is the ratio of the Imports(as % of merchandise exports) of Chad in 1972 to that in 1974?
Your answer should be very brief. 1.05. What is the ratio of the Imports(as % of merchandise exports) in Gambia, The in 1972 to that in 1974?
Offer a very short reply. 1.36. What is the ratio of the Imports(as % of merchandise exports) in Ireland in 1972 to that in 1974?
Give a very brief answer. 0.84. What is the ratio of the Imports(as % of merchandise exports) of Canada in 1972 to that in 1975?
Give a very brief answer. 1.25. What is the ratio of the Imports(as % of merchandise exports) of Chad in 1972 to that in 1975?
Your answer should be compact. 1.32. What is the ratio of the Imports(as % of merchandise exports) of Gambia, The in 1972 to that in 1975?
Keep it short and to the point. 1.57. What is the ratio of the Imports(as % of merchandise exports) of Ireland in 1972 to that in 1975?
Keep it short and to the point. 1.35. What is the ratio of the Imports(as % of merchandise exports) of Canada in 1972 to that in 1995?
Your answer should be very brief. 1.4. What is the ratio of the Imports(as % of merchandise exports) of Chad in 1972 to that in 1995?
Your answer should be compact. 3.11. What is the ratio of the Imports(as % of merchandise exports) of Gambia, The in 1972 to that in 1995?
Offer a very short reply. 5.56. What is the ratio of the Imports(as % of merchandise exports) of Ireland in 1972 to that in 1995?
Offer a terse response. 3.58. What is the ratio of the Imports(as % of merchandise exports) in Canada in 1973 to that in 1974?
Your answer should be very brief. 1.13. What is the ratio of the Imports(as % of merchandise exports) in Chad in 1973 to that in 1974?
Give a very brief answer. 1.07. What is the ratio of the Imports(as % of merchandise exports) of Gambia, The in 1973 to that in 1974?
Your answer should be compact. 1.45. What is the ratio of the Imports(as % of merchandise exports) in Ireland in 1973 to that in 1974?
Provide a succinct answer. 1.01. What is the ratio of the Imports(as % of merchandise exports) in Canada in 1973 to that in 1975?
Your response must be concise. 1.31. What is the ratio of the Imports(as % of merchandise exports) in Chad in 1973 to that in 1975?
Make the answer very short. 1.34. What is the ratio of the Imports(as % of merchandise exports) in Gambia, The in 1973 to that in 1975?
Ensure brevity in your answer.  1.68. What is the ratio of the Imports(as % of merchandise exports) of Ireland in 1973 to that in 1975?
Your answer should be very brief. 1.62. What is the ratio of the Imports(as % of merchandise exports) in Canada in 1973 to that in 1995?
Offer a terse response. 1.46. What is the ratio of the Imports(as % of merchandise exports) in Chad in 1973 to that in 1995?
Provide a succinct answer. 3.15. What is the ratio of the Imports(as % of merchandise exports) in Gambia, The in 1973 to that in 1995?
Provide a short and direct response. 5.95. What is the ratio of the Imports(as % of merchandise exports) of Ireland in 1973 to that in 1995?
Provide a succinct answer. 4.27. What is the ratio of the Imports(as % of merchandise exports) of Canada in 1974 to that in 1975?
Your answer should be very brief. 1.15. What is the ratio of the Imports(as % of merchandise exports) in Chad in 1974 to that in 1975?
Keep it short and to the point. 1.26. What is the ratio of the Imports(as % of merchandise exports) of Gambia, The in 1974 to that in 1975?
Your answer should be very brief. 1.16. What is the ratio of the Imports(as % of merchandise exports) in Ireland in 1974 to that in 1975?
Ensure brevity in your answer.  1.6. What is the ratio of the Imports(as % of merchandise exports) of Canada in 1974 to that in 1995?
Keep it short and to the point. 1.28. What is the ratio of the Imports(as % of merchandise exports) in Chad in 1974 to that in 1995?
Make the answer very short. 2.95. What is the ratio of the Imports(as % of merchandise exports) in Gambia, The in 1974 to that in 1995?
Give a very brief answer. 4.09. What is the ratio of the Imports(as % of merchandise exports) in Ireland in 1974 to that in 1995?
Give a very brief answer. 4.24. What is the ratio of the Imports(as % of merchandise exports) of Canada in 1975 to that in 1995?
Provide a succinct answer. 1.12. What is the ratio of the Imports(as % of merchandise exports) in Chad in 1975 to that in 1995?
Provide a short and direct response. 2.35. What is the ratio of the Imports(as % of merchandise exports) in Gambia, The in 1975 to that in 1995?
Ensure brevity in your answer.  3.54. What is the ratio of the Imports(as % of merchandise exports) of Ireland in 1975 to that in 1995?
Offer a very short reply. 2.65. What is the difference between the highest and the second highest Imports(as % of merchandise exports) in Canada?
Your answer should be very brief. 0.24. What is the difference between the highest and the second highest Imports(as % of merchandise exports) of Chad?
Keep it short and to the point. 0.01. What is the difference between the highest and the second highest Imports(as % of merchandise exports) of Gambia, The?
Give a very brief answer. 0.29. What is the difference between the highest and the second highest Imports(as % of merchandise exports) in Ireland?
Offer a terse response. 0.04. What is the difference between the highest and the lowest Imports(as % of merchandise exports) of Canada?
Ensure brevity in your answer.  1.02. What is the difference between the highest and the lowest Imports(as % of merchandise exports) in Chad?
Ensure brevity in your answer.  1.3. What is the difference between the highest and the lowest Imports(as % of merchandise exports) in Gambia, The?
Ensure brevity in your answer.  3.66. What is the difference between the highest and the lowest Imports(as % of merchandise exports) of Ireland?
Ensure brevity in your answer.  4.04. 